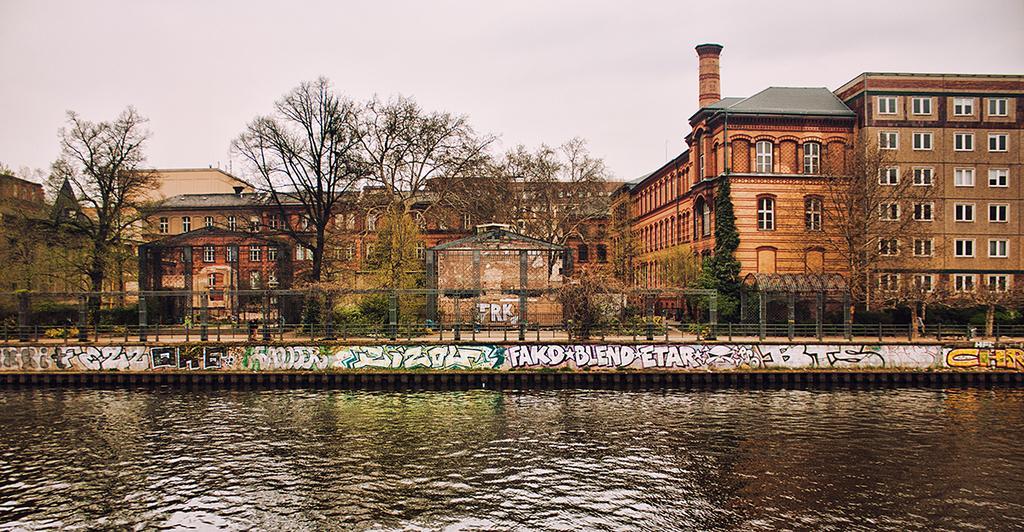Can you describe this image briefly? In this picture there is a brown building in the front with white color windows and dry trees. In the front both side there is a lake water. On the top there is a sky. 